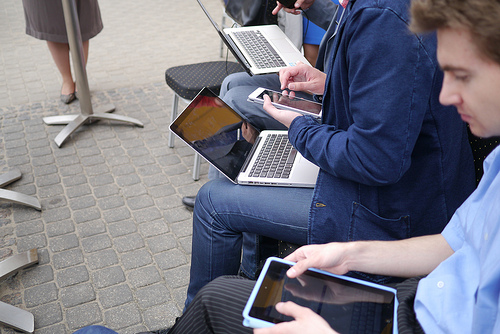Please provide a short description for this region: [0.04, 0.17, 0.22, 0.38]. The designated area shows a woman dressed semi-formally, wearing a skirt, likely engaged in a professional context or a casual business event. 